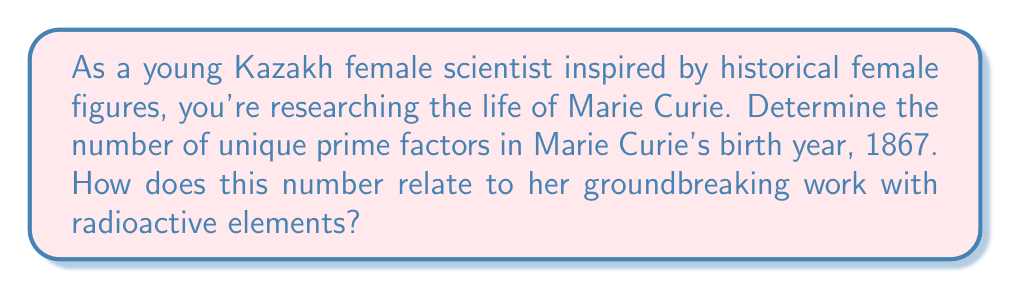Solve this math problem. Let's approach this step-by-step:

1) Marie Curie was born in 1867.

2) To find the prime factors of 1867, we need to decompose it into its prime factors:

   $1867 = 3 \times 7 \times 89$

3) We can verify this:
   $3 \times 7 \times 89 = 21 \times 89 = 1867$

4) Now, we need to count the number of unique prime factors. We have:
   - 3 (prime)
   - 7 (prime)
   - 89 (prime)

5) Therefore, 1867 has 3 unique prime factors.

Interestingly, this number (3) relates to Marie Curie's work in a symbolic way:

- She discovered three elements: polonium, radium, and actinium.
- She was the first person to win Nobel Prizes in three scientific fields: Physics and Chemistry, plus a medal in X-radiography.
- Her work focused on three types of radiation: alpha, beta, and gamma.

This connection between the number of prime factors in her birth year and her scientific achievements serves as a beautiful mathematical coincidence, highlighting the fundamental nature of both prime numbers in mathematics and Curie's contributions to our understanding of fundamental particles in physics and chemistry.
Answer: The number of unique prime factors in Marie Curie's birth year (1867) is 3. 